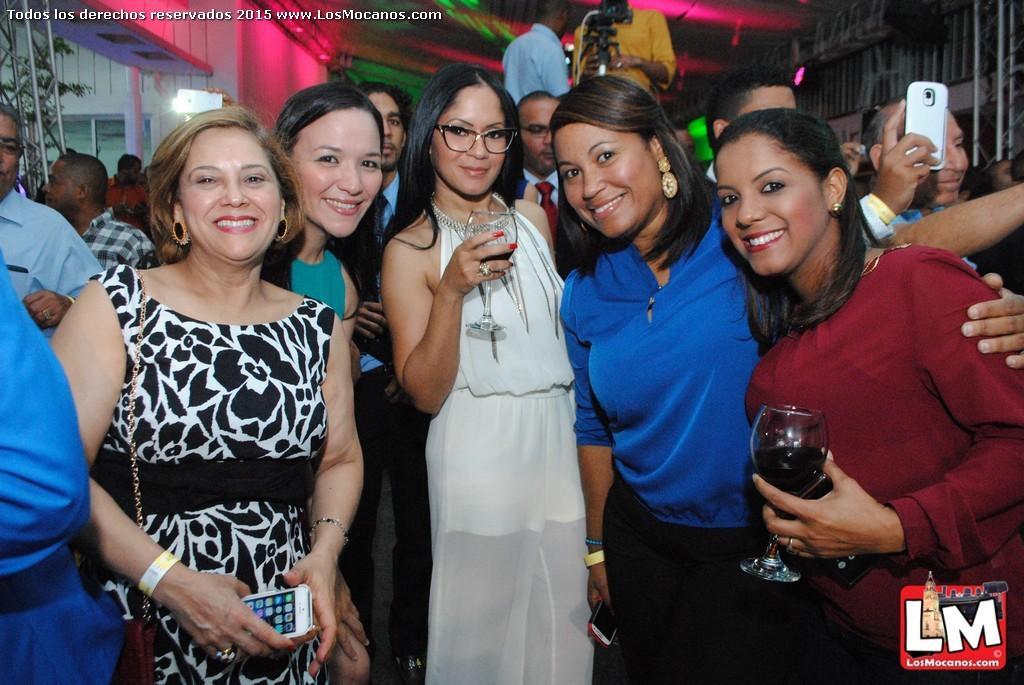Can you describe this image briefly? This Image is clicked in a function. There are so many people in this image ,five women are standing near by and it is like they might be clicking a picture, the person who is on the right side is holding a phone in his hand, the women on the right side with the brown shirt is holding a glass in her hand and women with white dress is also holding a glass and have specs to her eyes and the woman who is in the left side is holding phone and she is wearing bracelet. The man on the top is taking a video. 